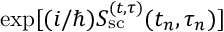Convert formula to latex. <formula><loc_0><loc_0><loc_500><loc_500>\exp [ ( i / \hbar { ) } S _ { s c } ^ { ( t , \tau ) } ( t _ { n } , \tau _ { n } ) ]</formula> 